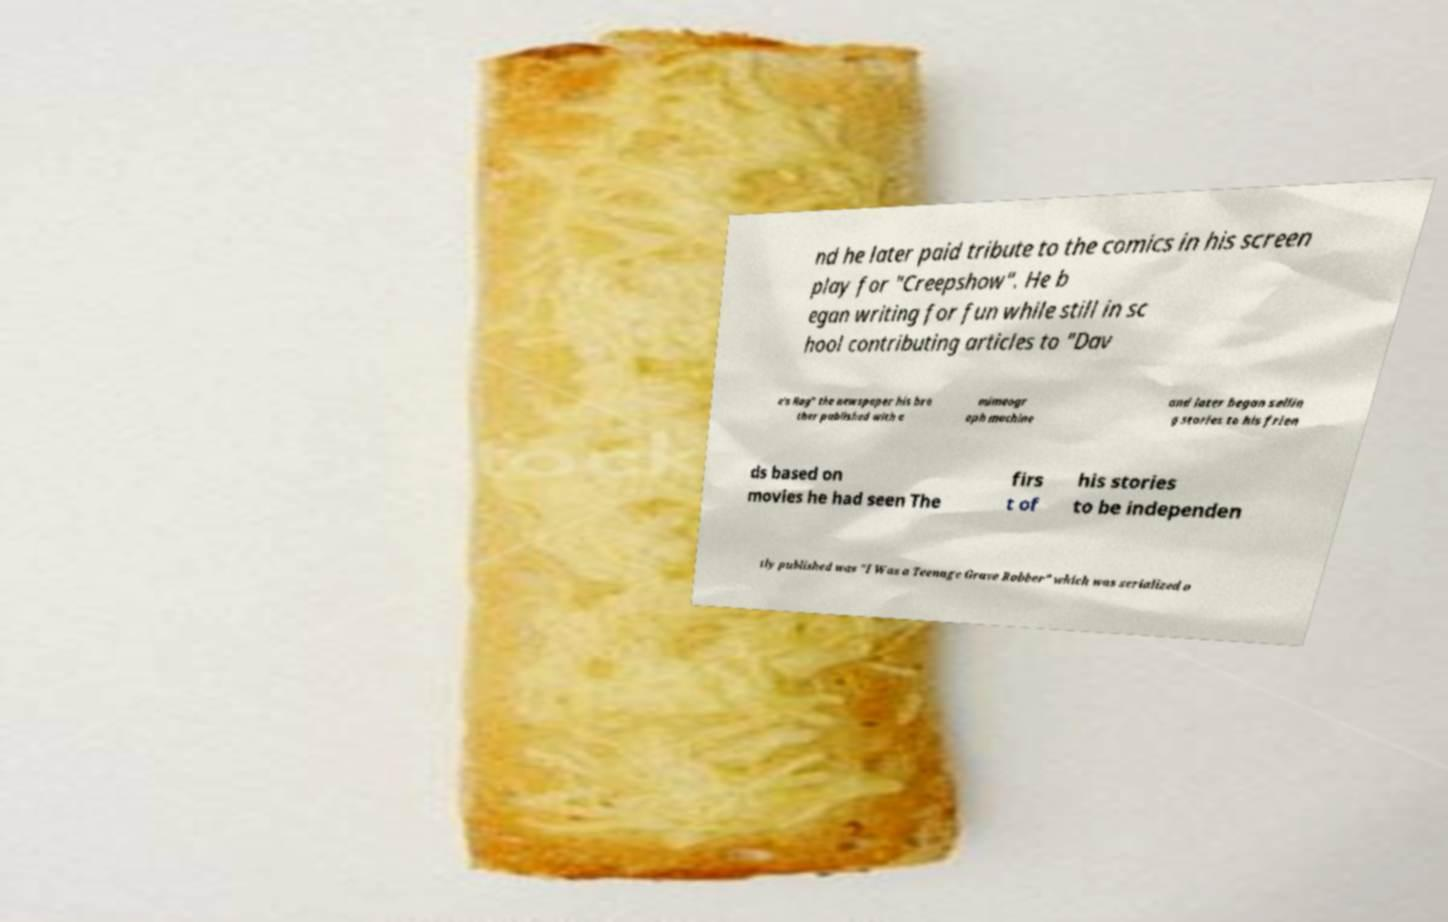Could you extract and type out the text from this image? nd he later paid tribute to the comics in his screen play for "Creepshow". He b egan writing for fun while still in sc hool contributing articles to "Dav e's Rag" the newspaper his bro ther published with a mimeogr aph machine and later began sellin g stories to his frien ds based on movies he had seen The firs t of his stories to be independen tly published was "I Was a Teenage Grave Robber" which was serialized o 